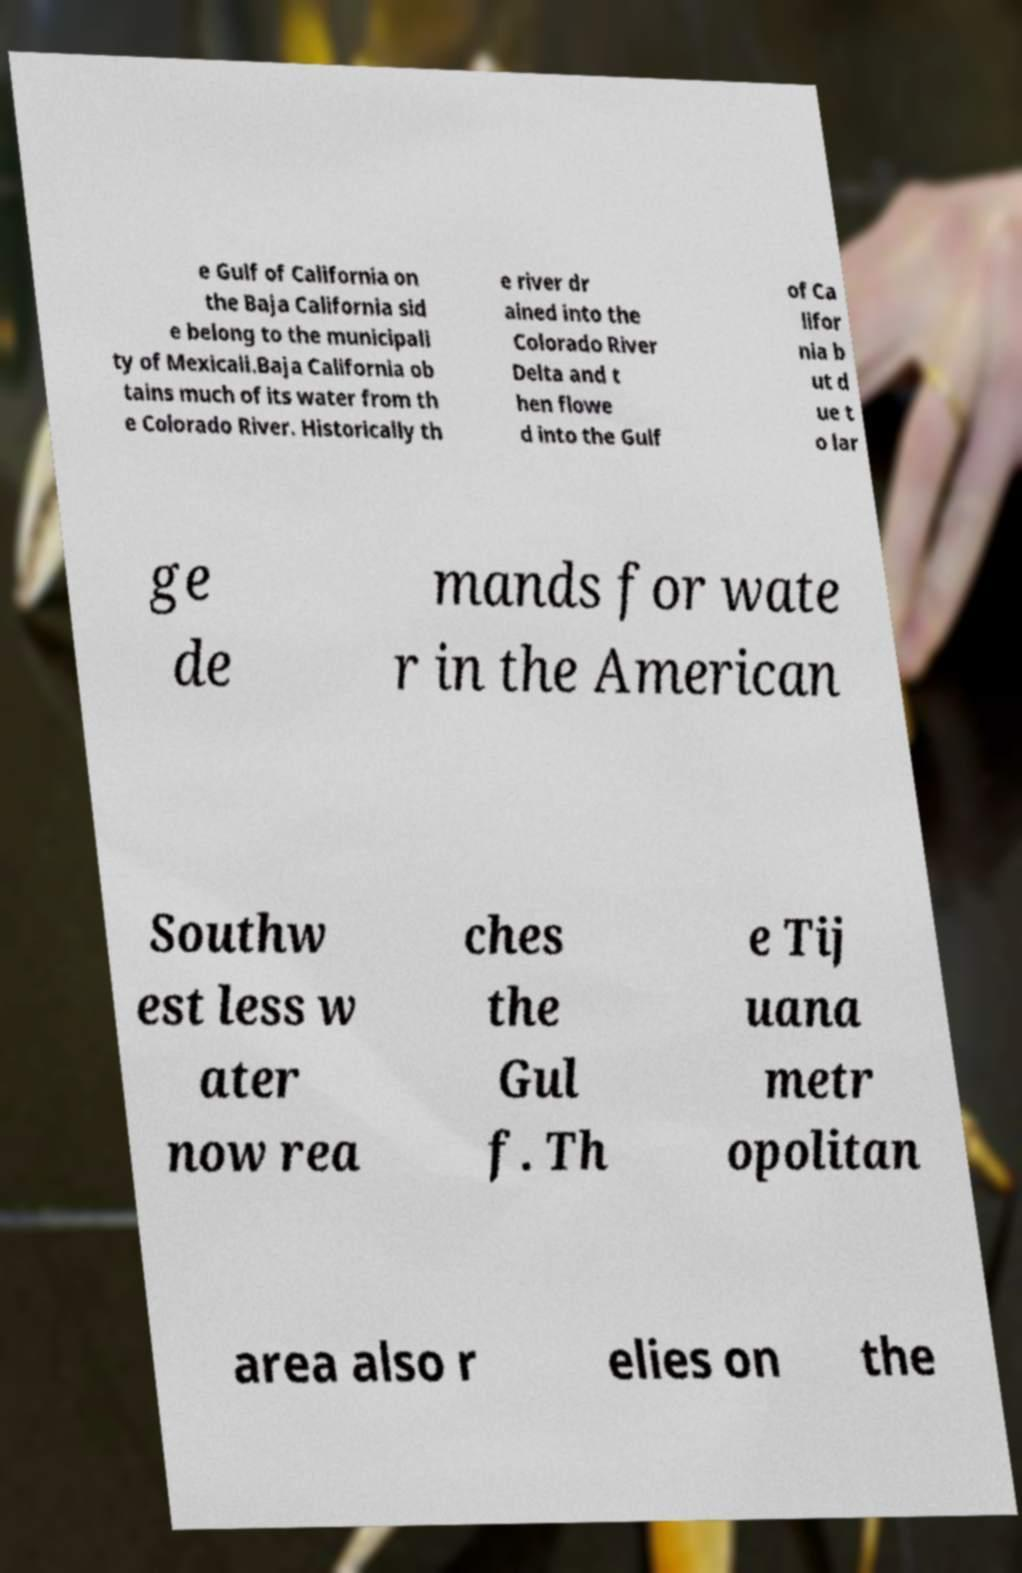Can you read and provide the text displayed in the image?This photo seems to have some interesting text. Can you extract and type it out for me? e Gulf of California on the Baja California sid e belong to the municipali ty of Mexicali.Baja California ob tains much of its water from th e Colorado River. Historically th e river dr ained into the Colorado River Delta and t hen flowe d into the Gulf of Ca lifor nia b ut d ue t o lar ge de mands for wate r in the American Southw est less w ater now rea ches the Gul f. Th e Tij uana metr opolitan area also r elies on the 